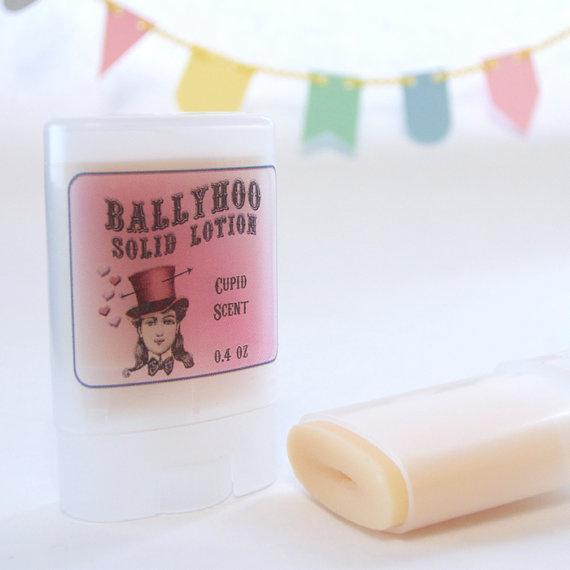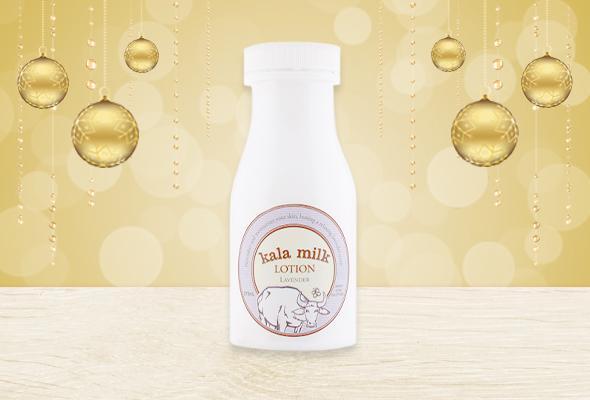The first image is the image on the left, the second image is the image on the right. Analyze the images presented: Is the assertion "A product is standing next to its box." valid? Answer yes or no. No. The first image is the image on the left, the second image is the image on the right. Examine the images to the left and right. Is the description "Each image contains exactly one product with a black pump top, and one image features a pump bottle with a yellow bow, but the pump nozzles on the left and right face different directions." accurate? Answer yes or no. No. 